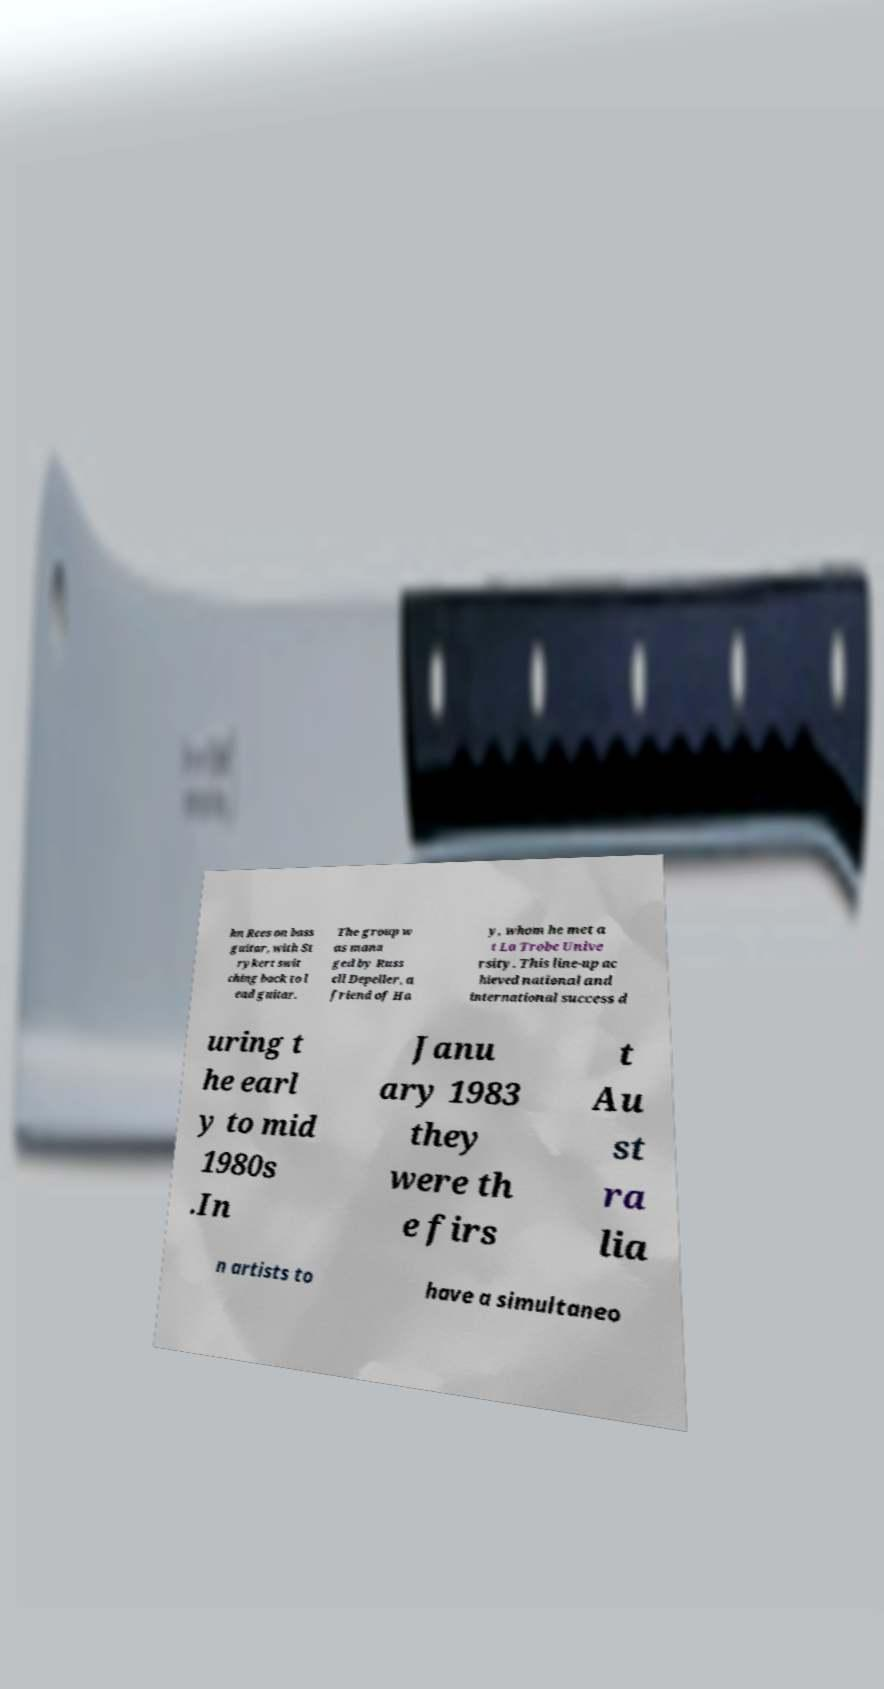For documentation purposes, I need the text within this image transcribed. Could you provide that? hn Rees on bass guitar, with St rykert swit ching back to l ead guitar. The group w as mana ged by Russ ell Depeller, a friend of Ha y, whom he met a t La Trobe Unive rsity. This line-up ac hieved national and international success d uring t he earl y to mid 1980s .In Janu ary 1983 they were th e firs t Au st ra lia n artists to have a simultaneo 